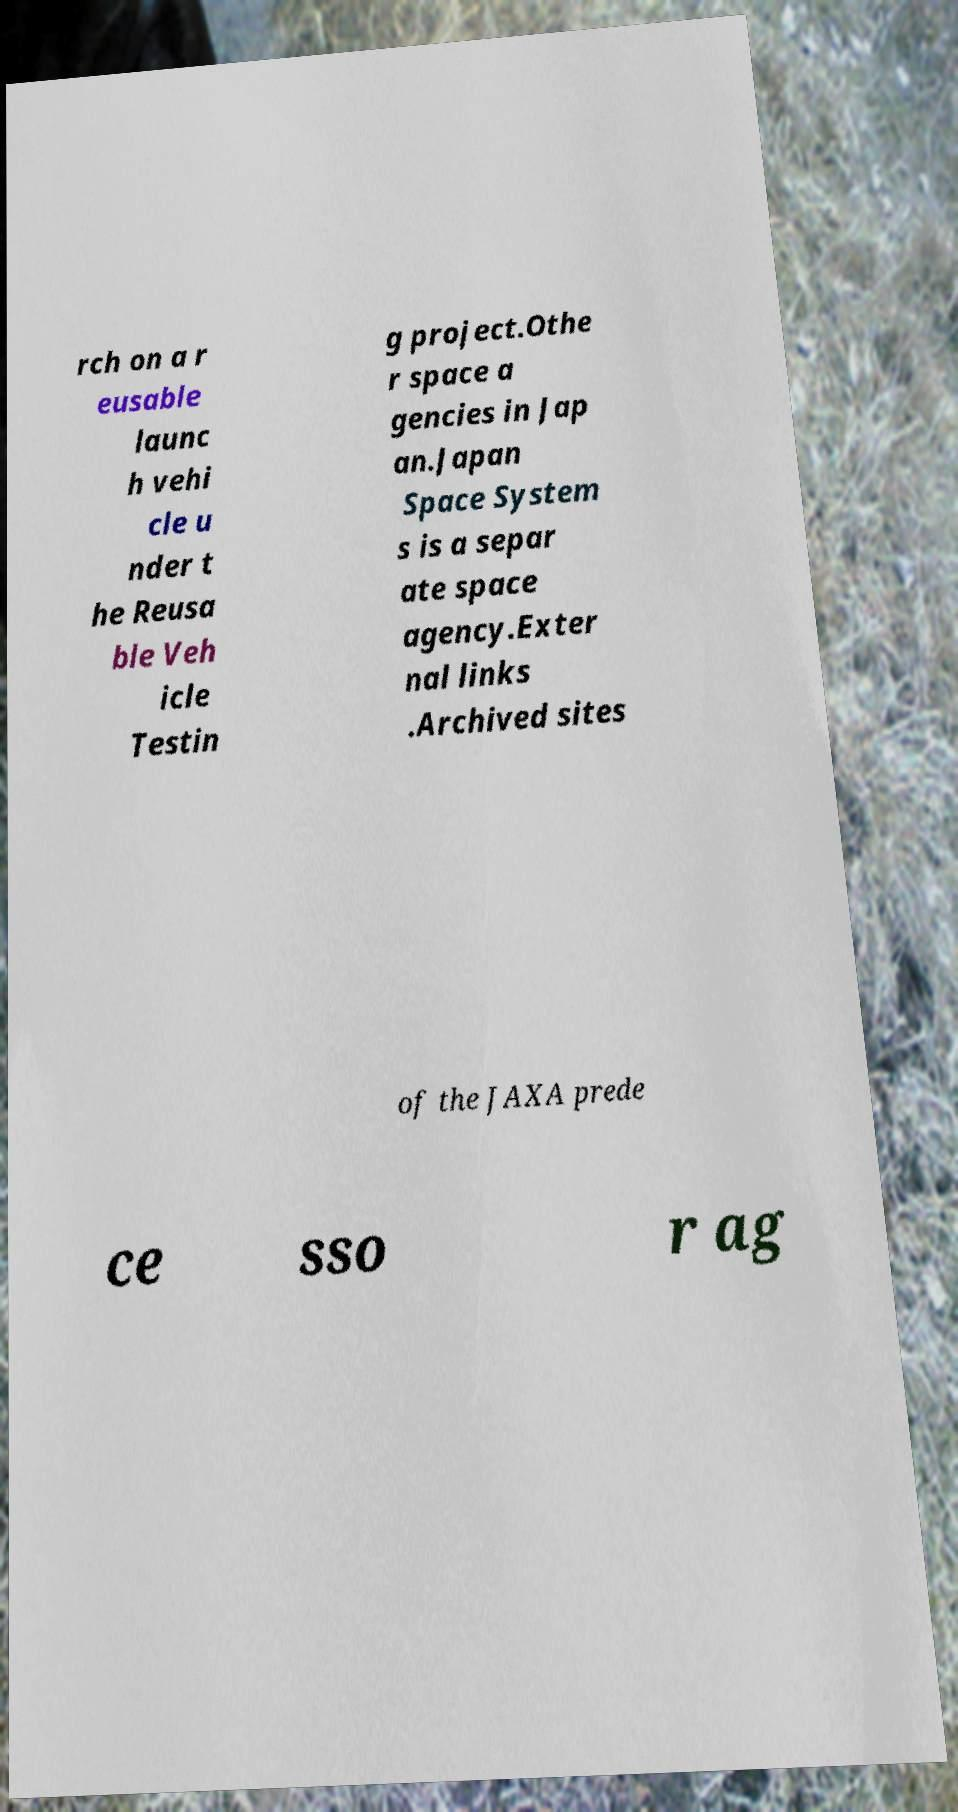For documentation purposes, I need the text within this image transcribed. Could you provide that? rch on a r eusable launc h vehi cle u nder t he Reusa ble Veh icle Testin g project.Othe r space a gencies in Jap an.Japan Space System s is a separ ate space agency.Exter nal links .Archived sites of the JAXA prede ce sso r ag 